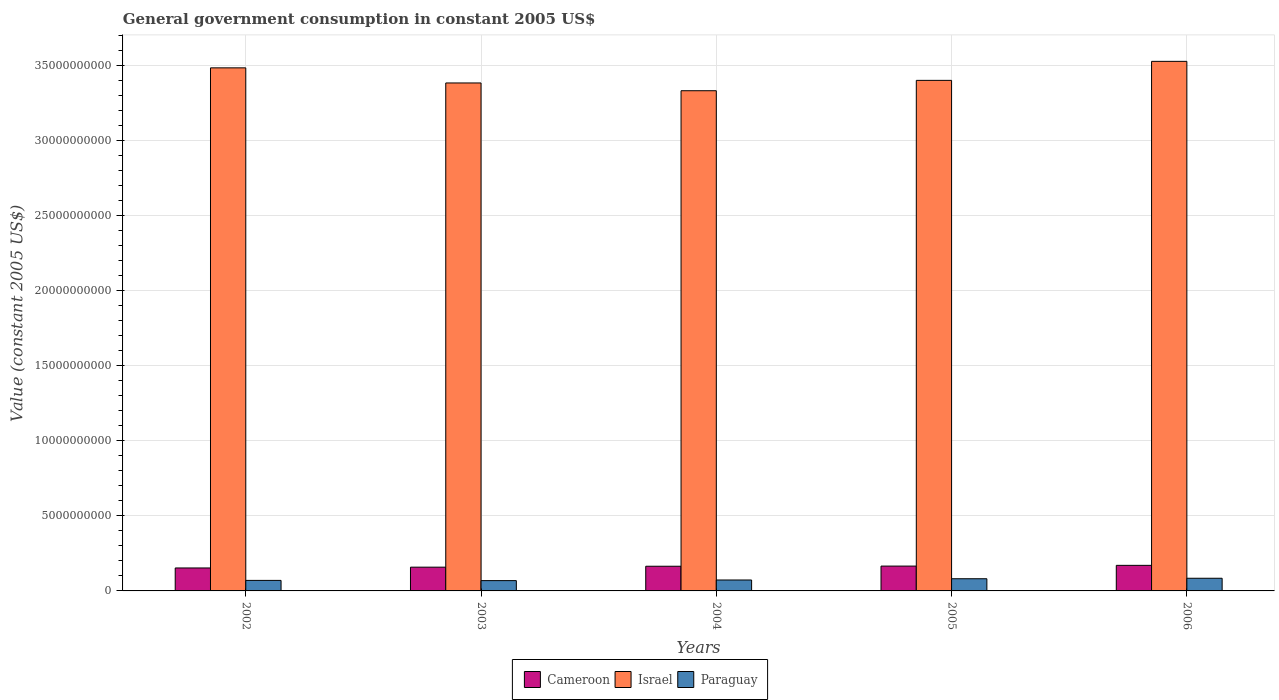What is the government conusmption in Israel in 2003?
Your answer should be very brief. 3.38e+1. Across all years, what is the maximum government conusmption in Cameroon?
Offer a very short reply. 1.70e+09. Across all years, what is the minimum government conusmption in Paraguay?
Give a very brief answer. 6.86e+08. In which year was the government conusmption in Paraguay minimum?
Provide a short and direct response. 2003. What is the total government conusmption in Paraguay in the graph?
Offer a very short reply. 3.77e+09. What is the difference between the government conusmption in Cameroon in 2002 and that in 2003?
Make the answer very short. -5.26e+07. What is the difference between the government conusmption in Paraguay in 2006 and the government conusmption in Cameroon in 2002?
Ensure brevity in your answer.  -6.85e+08. What is the average government conusmption in Paraguay per year?
Your answer should be very brief. 7.54e+08. In the year 2005, what is the difference between the government conusmption in Israel and government conusmption in Paraguay?
Ensure brevity in your answer.  3.32e+1. What is the ratio of the government conusmption in Israel in 2004 to that in 2005?
Provide a short and direct response. 0.98. What is the difference between the highest and the second highest government conusmption in Paraguay?
Provide a short and direct response. 3.24e+07. What is the difference between the highest and the lowest government conusmption in Cameroon?
Your response must be concise. 1.74e+08. Is the sum of the government conusmption in Cameroon in 2002 and 2005 greater than the maximum government conusmption in Paraguay across all years?
Ensure brevity in your answer.  Yes. What does the 1st bar from the left in 2004 represents?
Give a very brief answer. Cameroon. What does the 2nd bar from the right in 2003 represents?
Your answer should be compact. Israel. How many bars are there?
Offer a very short reply. 15. Are all the bars in the graph horizontal?
Your answer should be compact. No. Are the values on the major ticks of Y-axis written in scientific E-notation?
Make the answer very short. No. Does the graph contain grids?
Keep it short and to the point. Yes. How are the legend labels stacked?
Provide a succinct answer. Horizontal. What is the title of the graph?
Provide a short and direct response. General government consumption in constant 2005 US$. What is the label or title of the X-axis?
Offer a terse response. Years. What is the label or title of the Y-axis?
Make the answer very short. Value (constant 2005 US$). What is the Value (constant 2005 US$) in Cameroon in 2002?
Your answer should be very brief. 1.53e+09. What is the Value (constant 2005 US$) in Israel in 2002?
Provide a short and direct response. 3.48e+1. What is the Value (constant 2005 US$) of Paraguay in 2002?
Keep it short and to the point. 7.00e+08. What is the Value (constant 2005 US$) of Cameroon in 2003?
Your answer should be very brief. 1.58e+09. What is the Value (constant 2005 US$) in Israel in 2003?
Give a very brief answer. 3.38e+1. What is the Value (constant 2005 US$) of Paraguay in 2003?
Offer a terse response. 6.86e+08. What is the Value (constant 2005 US$) in Cameroon in 2004?
Give a very brief answer. 1.64e+09. What is the Value (constant 2005 US$) of Israel in 2004?
Your answer should be compact. 3.33e+1. What is the Value (constant 2005 US$) in Paraguay in 2004?
Ensure brevity in your answer.  7.28e+08. What is the Value (constant 2005 US$) of Cameroon in 2005?
Provide a short and direct response. 1.65e+09. What is the Value (constant 2005 US$) in Israel in 2005?
Your answer should be very brief. 3.40e+1. What is the Value (constant 2005 US$) of Paraguay in 2005?
Offer a very short reply. 8.11e+08. What is the Value (constant 2005 US$) of Cameroon in 2006?
Your response must be concise. 1.70e+09. What is the Value (constant 2005 US$) of Israel in 2006?
Ensure brevity in your answer.  3.52e+1. What is the Value (constant 2005 US$) in Paraguay in 2006?
Your answer should be very brief. 8.43e+08. Across all years, what is the maximum Value (constant 2005 US$) of Cameroon?
Give a very brief answer. 1.70e+09. Across all years, what is the maximum Value (constant 2005 US$) in Israel?
Your answer should be compact. 3.52e+1. Across all years, what is the maximum Value (constant 2005 US$) of Paraguay?
Offer a very short reply. 8.43e+08. Across all years, what is the minimum Value (constant 2005 US$) in Cameroon?
Provide a succinct answer. 1.53e+09. Across all years, what is the minimum Value (constant 2005 US$) in Israel?
Offer a terse response. 3.33e+1. Across all years, what is the minimum Value (constant 2005 US$) in Paraguay?
Your answer should be compact. 6.86e+08. What is the total Value (constant 2005 US$) in Cameroon in the graph?
Your answer should be compact. 8.11e+09. What is the total Value (constant 2005 US$) of Israel in the graph?
Make the answer very short. 1.71e+11. What is the total Value (constant 2005 US$) in Paraguay in the graph?
Make the answer very short. 3.77e+09. What is the difference between the Value (constant 2005 US$) of Cameroon in 2002 and that in 2003?
Make the answer very short. -5.26e+07. What is the difference between the Value (constant 2005 US$) in Israel in 2002 and that in 2003?
Make the answer very short. 1.01e+09. What is the difference between the Value (constant 2005 US$) of Paraguay in 2002 and that in 2003?
Provide a succinct answer. 1.40e+07. What is the difference between the Value (constant 2005 US$) of Cameroon in 2002 and that in 2004?
Ensure brevity in your answer.  -1.14e+08. What is the difference between the Value (constant 2005 US$) in Israel in 2002 and that in 2004?
Your response must be concise. 1.52e+09. What is the difference between the Value (constant 2005 US$) of Paraguay in 2002 and that in 2004?
Your answer should be compact. -2.74e+07. What is the difference between the Value (constant 2005 US$) in Cameroon in 2002 and that in 2005?
Offer a very short reply. -1.25e+08. What is the difference between the Value (constant 2005 US$) in Israel in 2002 and that in 2005?
Ensure brevity in your answer.  8.33e+08. What is the difference between the Value (constant 2005 US$) in Paraguay in 2002 and that in 2005?
Provide a short and direct response. -1.11e+08. What is the difference between the Value (constant 2005 US$) in Cameroon in 2002 and that in 2006?
Provide a short and direct response. -1.74e+08. What is the difference between the Value (constant 2005 US$) of Israel in 2002 and that in 2006?
Provide a short and direct response. -4.32e+08. What is the difference between the Value (constant 2005 US$) of Paraguay in 2002 and that in 2006?
Your response must be concise. -1.43e+08. What is the difference between the Value (constant 2005 US$) of Cameroon in 2003 and that in 2004?
Make the answer very short. -6.14e+07. What is the difference between the Value (constant 2005 US$) in Israel in 2003 and that in 2004?
Your answer should be very brief. 5.17e+08. What is the difference between the Value (constant 2005 US$) of Paraguay in 2003 and that in 2004?
Give a very brief answer. -4.14e+07. What is the difference between the Value (constant 2005 US$) in Cameroon in 2003 and that in 2005?
Give a very brief answer. -7.25e+07. What is the difference between the Value (constant 2005 US$) in Israel in 2003 and that in 2005?
Provide a succinct answer. -1.72e+08. What is the difference between the Value (constant 2005 US$) of Paraguay in 2003 and that in 2005?
Your answer should be very brief. -1.25e+08. What is the difference between the Value (constant 2005 US$) in Cameroon in 2003 and that in 2006?
Your response must be concise. -1.21e+08. What is the difference between the Value (constant 2005 US$) in Israel in 2003 and that in 2006?
Provide a short and direct response. -1.44e+09. What is the difference between the Value (constant 2005 US$) in Paraguay in 2003 and that in 2006?
Provide a short and direct response. -1.57e+08. What is the difference between the Value (constant 2005 US$) in Cameroon in 2004 and that in 2005?
Your answer should be very brief. -1.11e+07. What is the difference between the Value (constant 2005 US$) of Israel in 2004 and that in 2005?
Keep it short and to the point. -6.89e+08. What is the difference between the Value (constant 2005 US$) of Paraguay in 2004 and that in 2005?
Keep it short and to the point. -8.33e+07. What is the difference between the Value (constant 2005 US$) of Cameroon in 2004 and that in 2006?
Make the answer very short. -6.00e+07. What is the difference between the Value (constant 2005 US$) of Israel in 2004 and that in 2006?
Ensure brevity in your answer.  -1.95e+09. What is the difference between the Value (constant 2005 US$) of Paraguay in 2004 and that in 2006?
Ensure brevity in your answer.  -1.16e+08. What is the difference between the Value (constant 2005 US$) in Cameroon in 2005 and that in 2006?
Your answer should be compact. -4.88e+07. What is the difference between the Value (constant 2005 US$) of Israel in 2005 and that in 2006?
Your answer should be compact. -1.27e+09. What is the difference between the Value (constant 2005 US$) of Paraguay in 2005 and that in 2006?
Provide a succinct answer. -3.24e+07. What is the difference between the Value (constant 2005 US$) in Cameroon in 2002 and the Value (constant 2005 US$) in Israel in 2003?
Offer a very short reply. -3.23e+1. What is the difference between the Value (constant 2005 US$) in Cameroon in 2002 and the Value (constant 2005 US$) in Paraguay in 2003?
Give a very brief answer. 8.42e+08. What is the difference between the Value (constant 2005 US$) in Israel in 2002 and the Value (constant 2005 US$) in Paraguay in 2003?
Provide a succinct answer. 3.41e+1. What is the difference between the Value (constant 2005 US$) of Cameroon in 2002 and the Value (constant 2005 US$) of Israel in 2004?
Make the answer very short. -3.18e+1. What is the difference between the Value (constant 2005 US$) in Cameroon in 2002 and the Value (constant 2005 US$) in Paraguay in 2004?
Provide a short and direct response. 8.01e+08. What is the difference between the Value (constant 2005 US$) of Israel in 2002 and the Value (constant 2005 US$) of Paraguay in 2004?
Your response must be concise. 3.41e+1. What is the difference between the Value (constant 2005 US$) of Cameroon in 2002 and the Value (constant 2005 US$) of Israel in 2005?
Your answer should be very brief. -3.25e+1. What is the difference between the Value (constant 2005 US$) of Cameroon in 2002 and the Value (constant 2005 US$) of Paraguay in 2005?
Your response must be concise. 7.17e+08. What is the difference between the Value (constant 2005 US$) of Israel in 2002 and the Value (constant 2005 US$) of Paraguay in 2005?
Provide a succinct answer. 3.40e+1. What is the difference between the Value (constant 2005 US$) in Cameroon in 2002 and the Value (constant 2005 US$) in Israel in 2006?
Your answer should be compact. -3.37e+1. What is the difference between the Value (constant 2005 US$) in Cameroon in 2002 and the Value (constant 2005 US$) in Paraguay in 2006?
Keep it short and to the point. 6.85e+08. What is the difference between the Value (constant 2005 US$) of Israel in 2002 and the Value (constant 2005 US$) of Paraguay in 2006?
Make the answer very short. 3.40e+1. What is the difference between the Value (constant 2005 US$) of Cameroon in 2003 and the Value (constant 2005 US$) of Israel in 2004?
Ensure brevity in your answer.  -3.17e+1. What is the difference between the Value (constant 2005 US$) in Cameroon in 2003 and the Value (constant 2005 US$) in Paraguay in 2004?
Provide a short and direct response. 8.53e+08. What is the difference between the Value (constant 2005 US$) of Israel in 2003 and the Value (constant 2005 US$) of Paraguay in 2004?
Offer a very short reply. 3.31e+1. What is the difference between the Value (constant 2005 US$) in Cameroon in 2003 and the Value (constant 2005 US$) in Israel in 2005?
Your response must be concise. -3.24e+1. What is the difference between the Value (constant 2005 US$) of Cameroon in 2003 and the Value (constant 2005 US$) of Paraguay in 2005?
Ensure brevity in your answer.  7.70e+08. What is the difference between the Value (constant 2005 US$) of Israel in 2003 and the Value (constant 2005 US$) of Paraguay in 2005?
Your answer should be very brief. 3.30e+1. What is the difference between the Value (constant 2005 US$) in Cameroon in 2003 and the Value (constant 2005 US$) in Israel in 2006?
Keep it short and to the point. -3.37e+1. What is the difference between the Value (constant 2005 US$) of Cameroon in 2003 and the Value (constant 2005 US$) of Paraguay in 2006?
Your answer should be very brief. 7.37e+08. What is the difference between the Value (constant 2005 US$) of Israel in 2003 and the Value (constant 2005 US$) of Paraguay in 2006?
Keep it short and to the point. 3.30e+1. What is the difference between the Value (constant 2005 US$) in Cameroon in 2004 and the Value (constant 2005 US$) in Israel in 2005?
Your answer should be compact. -3.23e+1. What is the difference between the Value (constant 2005 US$) of Cameroon in 2004 and the Value (constant 2005 US$) of Paraguay in 2005?
Your response must be concise. 8.31e+08. What is the difference between the Value (constant 2005 US$) in Israel in 2004 and the Value (constant 2005 US$) in Paraguay in 2005?
Your response must be concise. 3.25e+1. What is the difference between the Value (constant 2005 US$) of Cameroon in 2004 and the Value (constant 2005 US$) of Israel in 2006?
Your answer should be compact. -3.36e+1. What is the difference between the Value (constant 2005 US$) in Cameroon in 2004 and the Value (constant 2005 US$) in Paraguay in 2006?
Make the answer very short. 7.99e+08. What is the difference between the Value (constant 2005 US$) of Israel in 2004 and the Value (constant 2005 US$) of Paraguay in 2006?
Your answer should be compact. 3.24e+1. What is the difference between the Value (constant 2005 US$) of Cameroon in 2005 and the Value (constant 2005 US$) of Israel in 2006?
Your response must be concise. -3.36e+1. What is the difference between the Value (constant 2005 US$) of Cameroon in 2005 and the Value (constant 2005 US$) of Paraguay in 2006?
Your answer should be very brief. 8.10e+08. What is the difference between the Value (constant 2005 US$) of Israel in 2005 and the Value (constant 2005 US$) of Paraguay in 2006?
Offer a terse response. 3.31e+1. What is the average Value (constant 2005 US$) in Cameroon per year?
Your answer should be compact. 1.62e+09. What is the average Value (constant 2005 US$) of Israel per year?
Give a very brief answer. 3.42e+1. What is the average Value (constant 2005 US$) in Paraguay per year?
Your answer should be compact. 7.54e+08. In the year 2002, what is the difference between the Value (constant 2005 US$) of Cameroon and Value (constant 2005 US$) of Israel?
Ensure brevity in your answer.  -3.33e+1. In the year 2002, what is the difference between the Value (constant 2005 US$) in Cameroon and Value (constant 2005 US$) in Paraguay?
Offer a terse response. 8.28e+08. In the year 2002, what is the difference between the Value (constant 2005 US$) of Israel and Value (constant 2005 US$) of Paraguay?
Make the answer very short. 3.41e+1. In the year 2003, what is the difference between the Value (constant 2005 US$) of Cameroon and Value (constant 2005 US$) of Israel?
Keep it short and to the point. -3.22e+1. In the year 2003, what is the difference between the Value (constant 2005 US$) in Cameroon and Value (constant 2005 US$) in Paraguay?
Ensure brevity in your answer.  8.95e+08. In the year 2003, what is the difference between the Value (constant 2005 US$) of Israel and Value (constant 2005 US$) of Paraguay?
Your answer should be compact. 3.31e+1. In the year 2004, what is the difference between the Value (constant 2005 US$) in Cameroon and Value (constant 2005 US$) in Israel?
Your answer should be compact. -3.16e+1. In the year 2004, what is the difference between the Value (constant 2005 US$) of Cameroon and Value (constant 2005 US$) of Paraguay?
Give a very brief answer. 9.15e+08. In the year 2004, what is the difference between the Value (constant 2005 US$) in Israel and Value (constant 2005 US$) in Paraguay?
Your response must be concise. 3.26e+1. In the year 2005, what is the difference between the Value (constant 2005 US$) of Cameroon and Value (constant 2005 US$) of Israel?
Give a very brief answer. -3.23e+1. In the year 2005, what is the difference between the Value (constant 2005 US$) of Cameroon and Value (constant 2005 US$) of Paraguay?
Offer a terse response. 8.42e+08. In the year 2005, what is the difference between the Value (constant 2005 US$) in Israel and Value (constant 2005 US$) in Paraguay?
Ensure brevity in your answer.  3.32e+1. In the year 2006, what is the difference between the Value (constant 2005 US$) of Cameroon and Value (constant 2005 US$) of Israel?
Ensure brevity in your answer.  -3.35e+1. In the year 2006, what is the difference between the Value (constant 2005 US$) of Cameroon and Value (constant 2005 US$) of Paraguay?
Provide a succinct answer. 8.59e+08. In the year 2006, what is the difference between the Value (constant 2005 US$) of Israel and Value (constant 2005 US$) of Paraguay?
Offer a terse response. 3.44e+1. What is the ratio of the Value (constant 2005 US$) in Cameroon in 2002 to that in 2003?
Your answer should be very brief. 0.97. What is the ratio of the Value (constant 2005 US$) of Israel in 2002 to that in 2003?
Your answer should be compact. 1.03. What is the ratio of the Value (constant 2005 US$) in Paraguay in 2002 to that in 2003?
Keep it short and to the point. 1.02. What is the ratio of the Value (constant 2005 US$) in Cameroon in 2002 to that in 2004?
Provide a succinct answer. 0.93. What is the ratio of the Value (constant 2005 US$) of Israel in 2002 to that in 2004?
Give a very brief answer. 1.05. What is the ratio of the Value (constant 2005 US$) in Paraguay in 2002 to that in 2004?
Offer a very short reply. 0.96. What is the ratio of the Value (constant 2005 US$) of Cameroon in 2002 to that in 2005?
Your response must be concise. 0.92. What is the ratio of the Value (constant 2005 US$) in Israel in 2002 to that in 2005?
Make the answer very short. 1.02. What is the ratio of the Value (constant 2005 US$) in Paraguay in 2002 to that in 2005?
Give a very brief answer. 0.86. What is the ratio of the Value (constant 2005 US$) in Cameroon in 2002 to that in 2006?
Offer a terse response. 0.9. What is the ratio of the Value (constant 2005 US$) of Paraguay in 2002 to that in 2006?
Your response must be concise. 0.83. What is the ratio of the Value (constant 2005 US$) of Cameroon in 2003 to that in 2004?
Provide a succinct answer. 0.96. What is the ratio of the Value (constant 2005 US$) in Israel in 2003 to that in 2004?
Offer a very short reply. 1.02. What is the ratio of the Value (constant 2005 US$) of Paraguay in 2003 to that in 2004?
Ensure brevity in your answer.  0.94. What is the ratio of the Value (constant 2005 US$) of Cameroon in 2003 to that in 2005?
Provide a short and direct response. 0.96. What is the ratio of the Value (constant 2005 US$) in Paraguay in 2003 to that in 2005?
Your response must be concise. 0.85. What is the ratio of the Value (constant 2005 US$) in Cameroon in 2003 to that in 2006?
Keep it short and to the point. 0.93. What is the ratio of the Value (constant 2005 US$) in Israel in 2003 to that in 2006?
Make the answer very short. 0.96. What is the ratio of the Value (constant 2005 US$) of Paraguay in 2003 to that in 2006?
Offer a terse response. 0.81. What is the ratio of the Value (constant 2005 US$) in Cameroon in 2004 to that in 2005?
Ensure brevity in your answer.  0.99. What is the ratio of the Value (constant 2005 US$) of Israel in 2004 to that in 2005?
Offer a very short reply. 0.98. What is the ratio of the Value (constant 2005 US$) in Paraguay in 2004 to that in 2005?
Keep it short and to the point. 0.9. What is the ratio of the Value (constant 2005 US$) in Cameroon in 2004 to that in 2006?
Provide a succinct answer. 0.96. What is the ratio of the Value (constant 2005 US$) in Israel in 2004 to that in 2006?
Offer a terse response. 0.94. What is the ratio of the Value (constant 2005 US$) of Paraguay in 2004 to that in 2006?
Make the answer very short. 0.86. What is the ratio of the Value (constant 2005 US$) in Cameroon in 2005 to that in 2006?
Your response must be concise. 0.97. What is the ratio of the Value (constant 2005 US$) in Israel in 2005 to that in 2006?
Provide a short and direct response. 0.96. What is the ratio of the Value (constant 2005 US$) in Paraguay in 2005 to that in 2006?
Provide a short and direct response. 0.96. What is the difference between the highest and the second highest Value (constant 2005 US$) of Cameroon?
Keep it short and to the point. 4.88e+07. What is the difference between the highest and the second highest Value (constant 2005 US$) in Israel?
Give a very brief answer. 4.32e+08. What is the difference between the highest and the second highest Value (constant 2005 US$) of Paraguay?
Keep it short and to the point. 3.24e+07. What is the difference between the highest and the lowest Value (constant 2005 US$) in Cameroon?
Give a very brief answer. 1.74e+08. What is the difference between the highest and the lowest Value (constant 2005 US$) in Israel?
Make the answer very short. 1.95e+09. What is the difference between the highest and the lowest Value (constant 2005 US$) of Paraguay?
Your answer should be compact. 1.57e+08. 